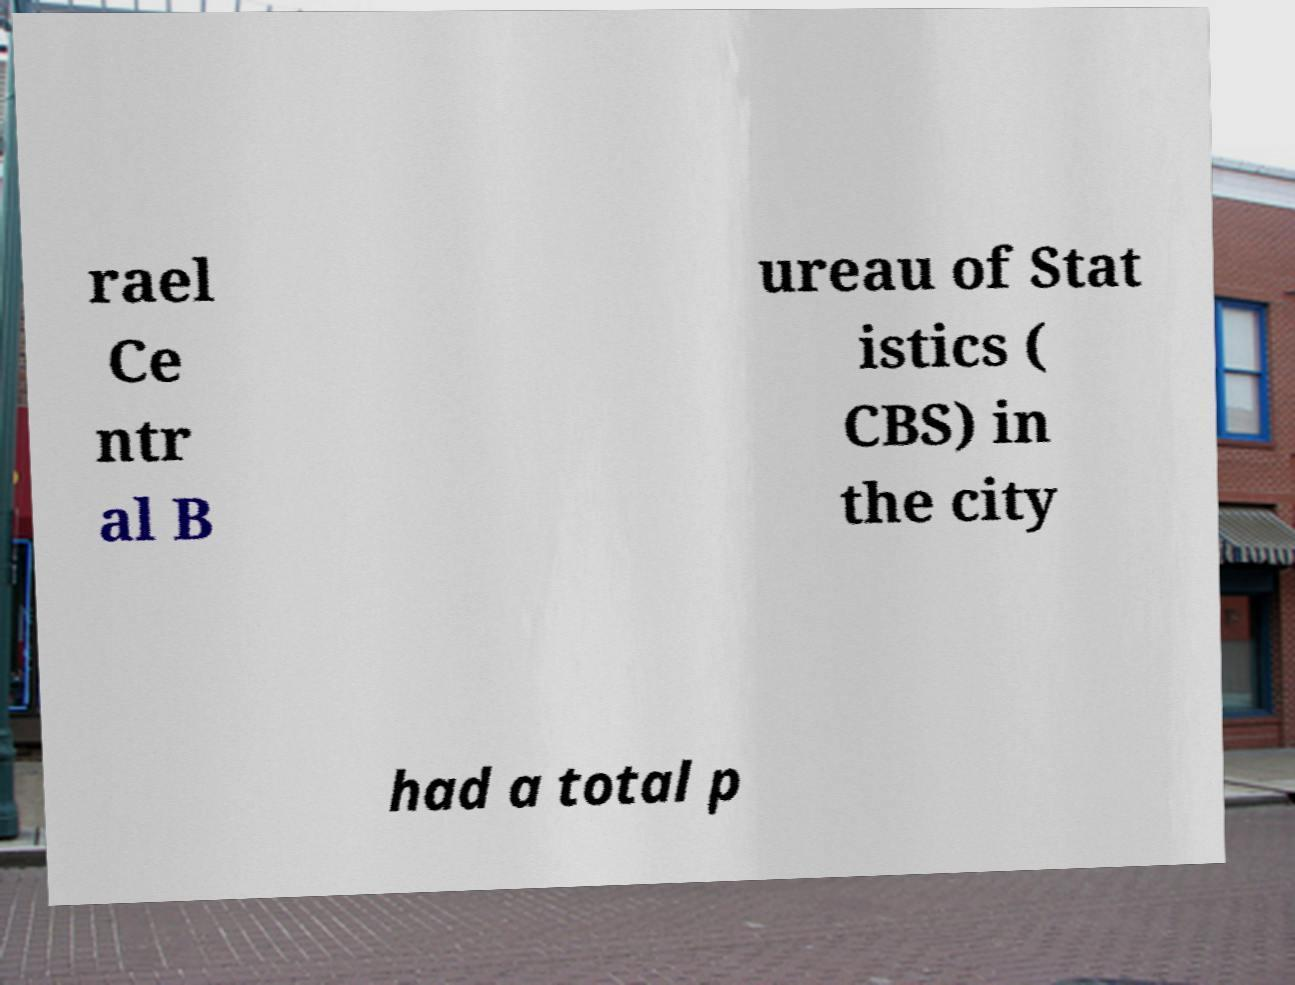What messages or text are displayed in this image? I need them in a readable, typed format. rael Ce ntr al B ureau of Stat istics ( CBS) in the city had a total p 